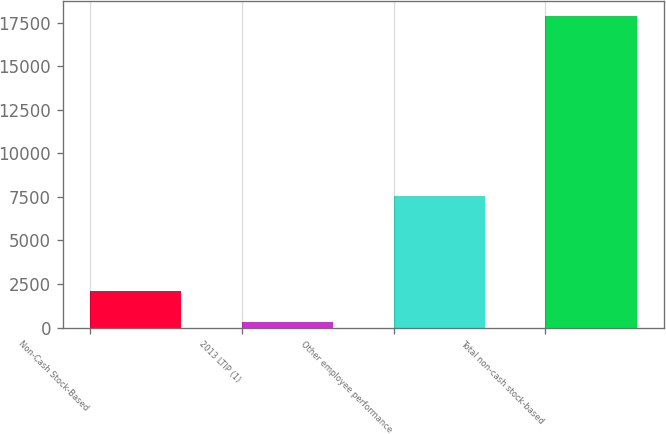Convert chart to OTSL. <chart><loc_0><loc_0><loc_500><loc_500><bar_chart><fcel>Non-Cash Stock-Based<fcel>2013 LTIP (1)<fcel>Other employee performance<fcel>Total non-cash stock-based<nl><fcel>2075.7<fcel>321<fcel>7549<fcel>17868<nl></chart> 